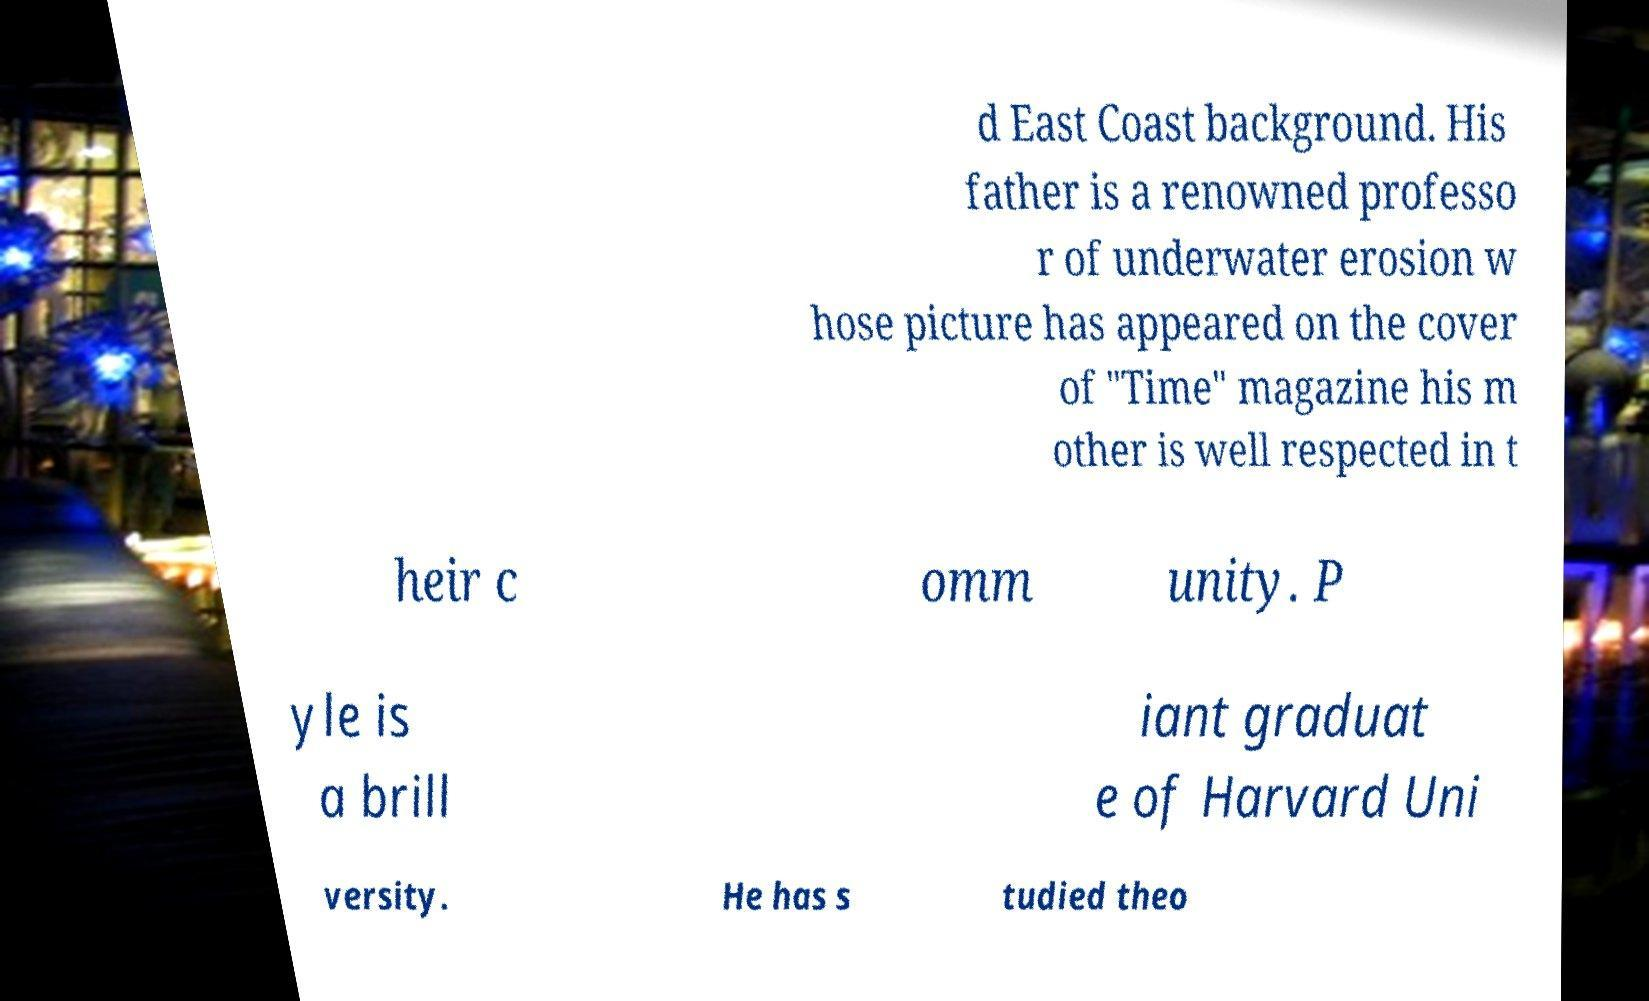Can you read and provide the text displayed in the image?This photo seems to have some interesting text. Can you extract and type it out for me? d East Coast background. His father is a renowned professo r of underwater erosion w hose picture has appeared on the cover of "Time" magazine his m other is well respected in t heir c omm unity. P yle is a brill iant graduat e of Harvard Uni versity. He has s tudied theo 